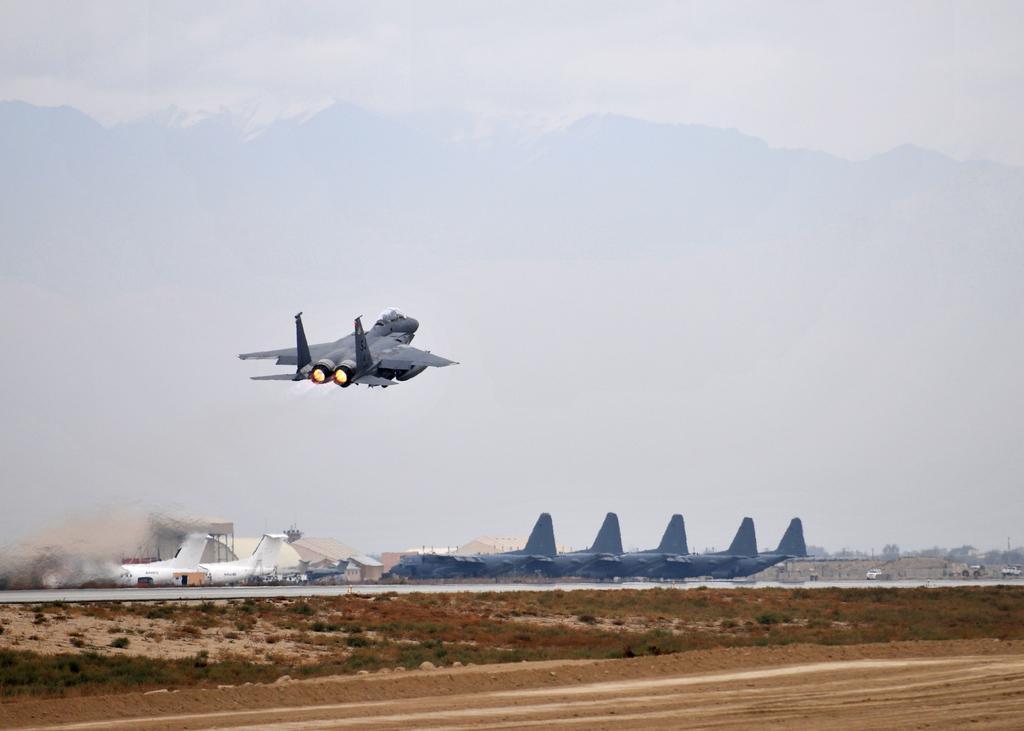Describe this image in one or two sentences. In this image we can see a jet plane in the sky. The sky looks cloudy. On the bottom of the image we can see some airplanes on the ground, some houses, trees, vehicles and some plants. 